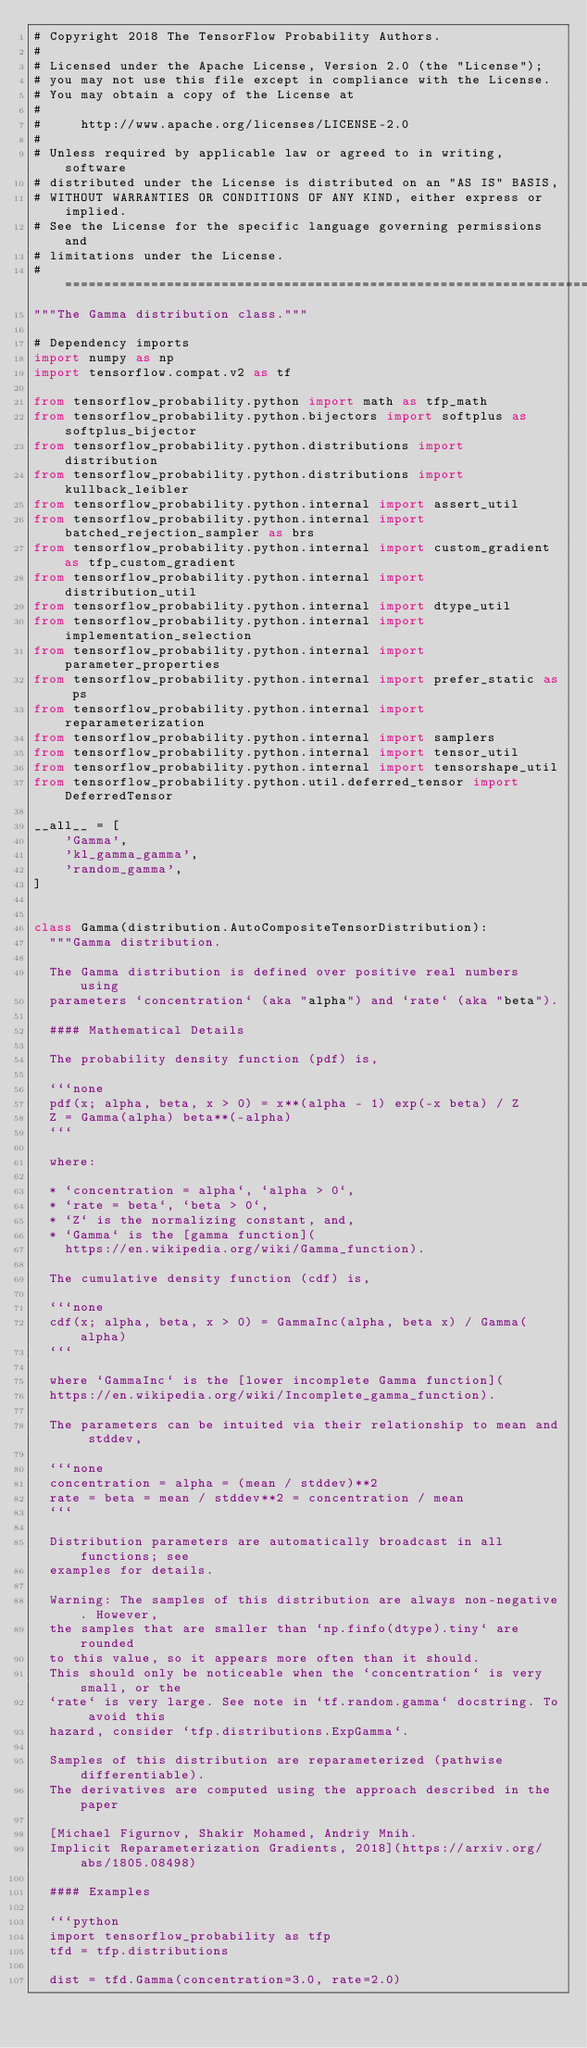<code> <loc_0><loc_0><loc_500><loc_500><_Python_># Copyright 2018 The TensorFlow Probability Authors.
#
# Licensed under the Apache License, Version 2.0 (the "License");
# you may not use this file except in compliance with the License.
# You may obtain a copy of the License at
#
#     http://www.apache.org/licenses/LICENSE-2.0
#
# Unless required by applicable law or agreed to in writing, software
# distributed under the License is distributed on an "AS IS" BASIS,
# WITHOUT WARRANTIES OR CONDITIONS OF ANY KIND, either express or implied.
# See the License for the specific language governing permissions and
# limitations under the License.
# ============================================================================
"""The Gamma distribution class."""

# Dependency imports
import numpy as np
import tensorflow.compat.v2 as tf

from tensorflow_probability.python import math as tfp_math
from tensorflow_probability.python.bijectors import softplus as softplus_bijector
from tensorflow_probability.python.distributions import distribution
from tensorflow_probability.python.distributions import kullback_leibler
from tensorflow_probability.python.internal import assert_util
from tensorflow_probability.python.internal import batched_rejection_sampler as brs
from tensorflow_probability.python.internal import custom_gradient as tfp_custom_gradient
from tensorflow_probability.python.internal import distribution_util
from tensorflow_probability.python.internal import dtype_util
from tensorflow_probability.python.internal import implementation_selection
from tensorflow_probability.python.internal import parameter_properties
from tensorflow_probability.python.internal import prefer_static as ps
from tensorflow_probability.python.internal import reparameterization
from tensorflow_probability.python.internal import samplers
from tensorflow_probability.python.internal import tensor_util
from tensorflow_probability.python.internal import tensorshape_util
from tensorflow_probability.python.util.deferred_tensor import DeferredTensor

__all__ = [
    'Gamma',
    'kl_gamma_gamma',
    'random_gamma',
]


class Gamma(distribution.AutoCompositeTensorDistribution):
  """Gamma distribution.

  The Gamma distribution is defined over positive real numbers using
  parameters `concentration` (aka "alpha") and `rate` (aka "beta").

  #### Mathematical Details

  The probability density function (pdf) is,

  ```none
  pdf(x; alpha, beta, x > 0) = x**(alpha - 1) exp(-x beta) / Z
  Z = Gamma(alpha) beta**(-alpha)
  ```

  where:

  * `concentration = alpha`, `alpha > 0`,
  * `rate = beta`, `beta > 0`,
  * `Z` is the normalizing constant, and,
  * `Gamma` is the [gamma function](
    https://en.wikipedia.org/wiki/Gamma_function).

  The cumulative density function (cdf) is,

  ```none
  cdf(x; alpha, beta, x > 0) = GammaInc(alpha, beta x) / Gamma(alpha)
  ```

  where `GammaInc` is the [lower incomplete Gamma function](
  https://en.wikipedia.org/wiki/Incomplete_gamma_function).

  The parameters can be intuited via their relationship to mean and stddev,

  ```none
  concentration = alpha = (mean / stddev)**2
  rate = beta = mean / stddev**2 = concentration / mean
  ```

  Distribution parameters are automatically broadcast in all functions; see
  examples for details.

  Warning: The samples of this distribution are always non-negative. However,
  the samples that are smaller than `np.finfo(dtype).tiny` are rounded
  to this value, so it appears more often than it should.
  This should only be noticeable when the `concentration` is very small, or the
  `rate` is very large. See note in `tf.random.gamma` docstring. To avoid this
  hazard, consider `tfp.distributions.ExpGamma`.

  Samples of this distribution are reparameterized (pathwise differentiable).
  The derivatives are computed using the approach described in the paper

  [Michael Figurnov, Shakir Mohamed, Andriy Mnih.
  Implicit Reparameterization Gradients, 2018](https://arxiv.org/abs/1805.08498)

  #### Examples

  ```python
  import tensorflow_probability as tfp
  tfd = tfp.distributions

  dist = tfd.Gamma(concentration=3.0, rate=2.0)</code> 